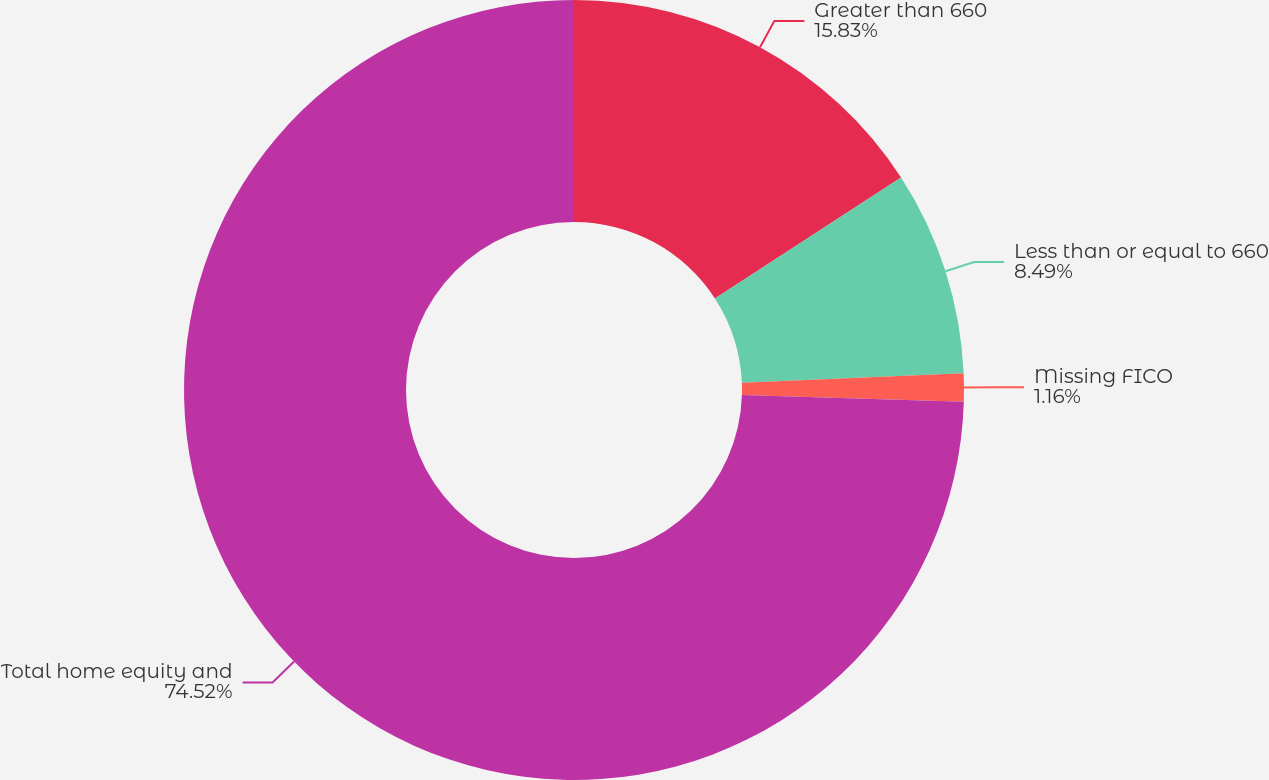<chart> <loc_0><loc_0><loc_500><loc_500><pie_chart><fcel>Greater than 660<fcel>Less than or equal to 660<fcel>Missing FICO<fcel>Total home equity and<nl><fcel>15.83%<fcel>8.49%<fcel>1.16%<fcel>74.52%<nl></chart> 